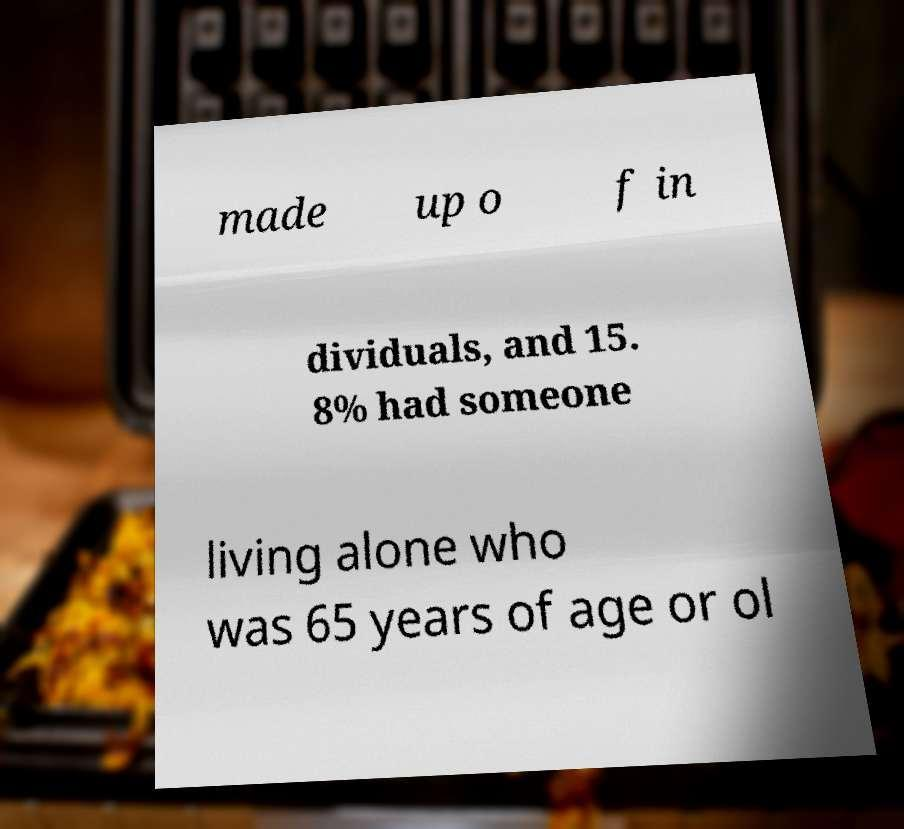Can you accurately transcribe the text from the provided image for me? made up o f in dividuals, and 15. 8% had someone living alone who was 65 years of age or ol 